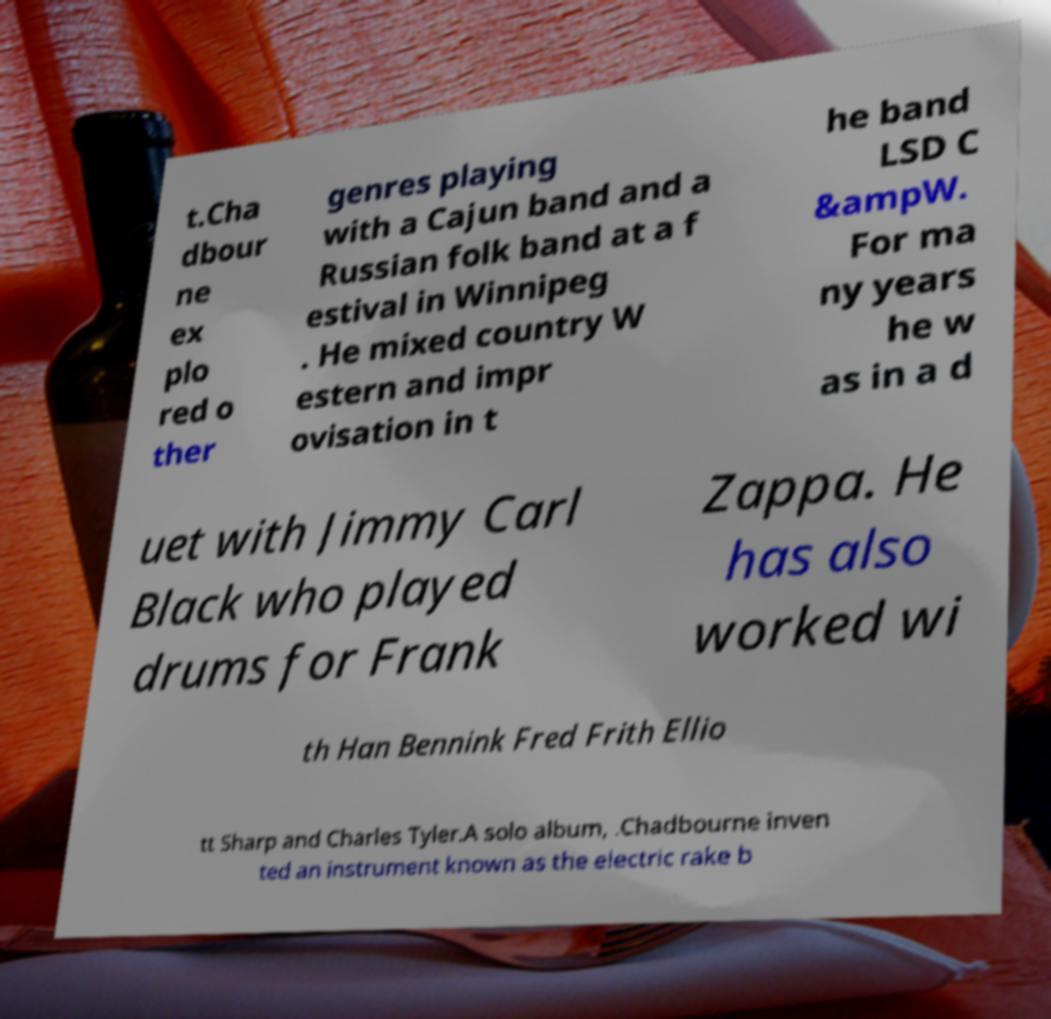There's text embedded in this image that I need extracted. Can you transcribe it verbatim? t.Cha dbour ne ex plo red o ther genres playing with a Cajun band and a Russian folk band at a f estival in Winnipeg . He mixed country W estern and impr ovisation in t he band LSD C &ampW. For ma ny years he w as in a d uet with Jimmy Carl Black who played drums for Frank Zappa. He has also worked wi th Han Bennink Fred Frith Ellio tt Sharp and Charles Tyler.A solo album, .Chadbourne inven ted an instrument known as the electric rake b 